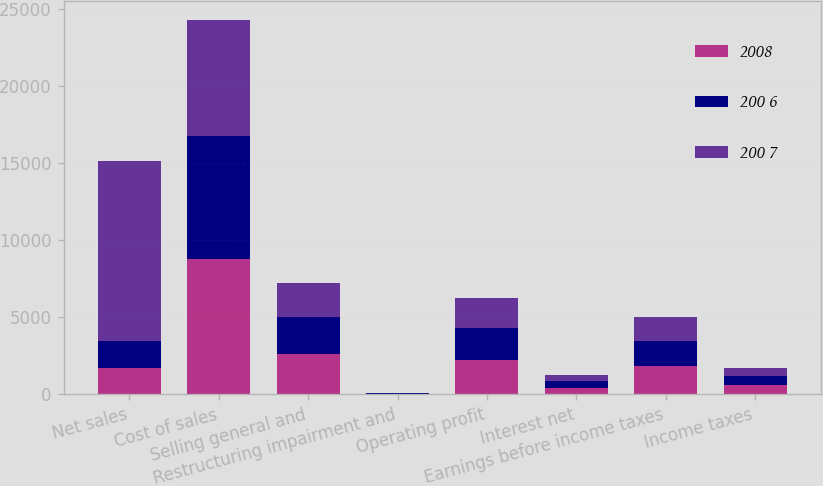<chart> <loc_0><loc_0><loc_500><loc_500><stacked_bar_chart><ecel><fcel>Net sales<fcel>Cost of sales<fcel>Selling general and<fcel>Restructuring impairment and<fcel>Operating profit<fcel>Interest net<fcel>Earnings before income taxes<fcel>Income taxes<nl><fcel>2008<fcel>1718.7<fcel>8778.3<fcel>2625<fcel>21<fcel>2227.8<fcel>421.7<fcel>1806.1<fcel>622.2<nl><fcel>200 6<fcel>1718.7<fcel>7955.1<fcel>2389.3<fcel>39.3<fcel>2057.8<fcel>426.5<fcel>1631.3<fcel>560.1<nl><fcel>200 7<fcel>11711.3<fcel>7544.8<fcel>2177.7<fcel>29.8<fcel>1959<fcel>399.6<fcel>1559.4<fcel>538.3<nl></chart> 